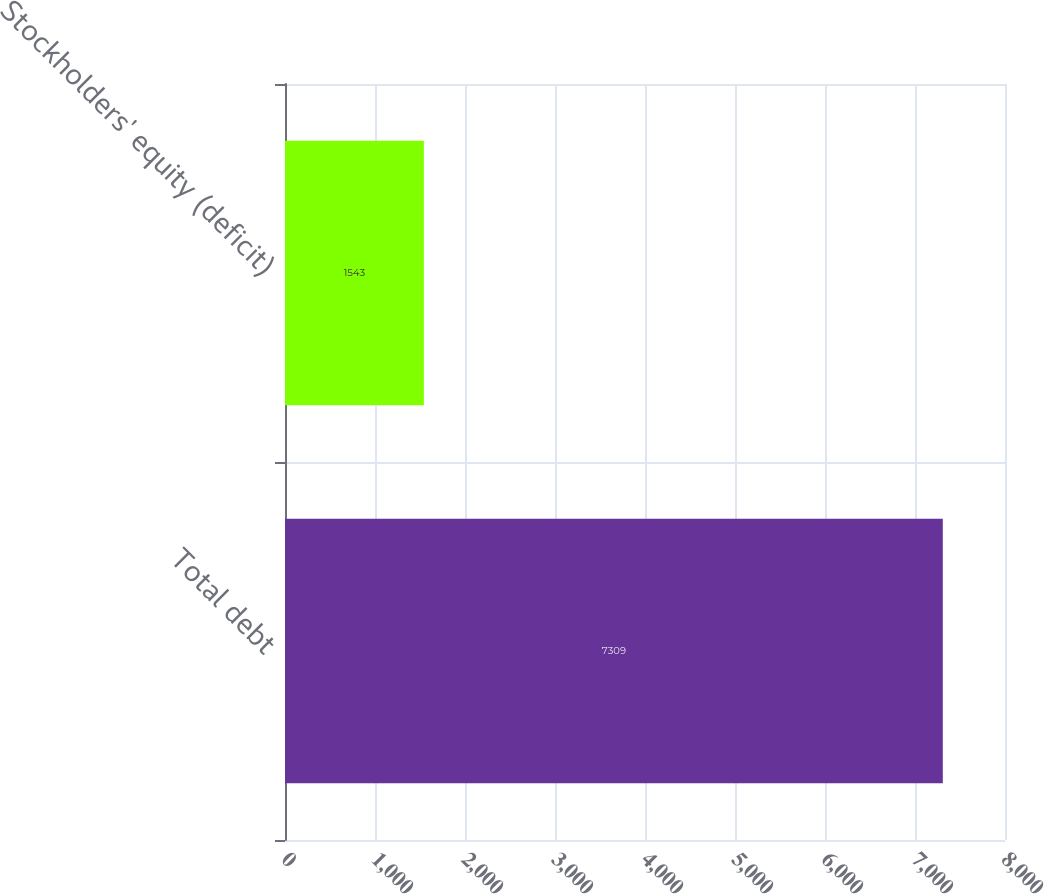Convert chart. <chart><loc_0><loc_0><loc_500><loc_500><bar_chart><fcel>Total debt<fcel>Stockholders' equity (deficit)<nl><fcel>7309<fcel>1543<nl></chart> 